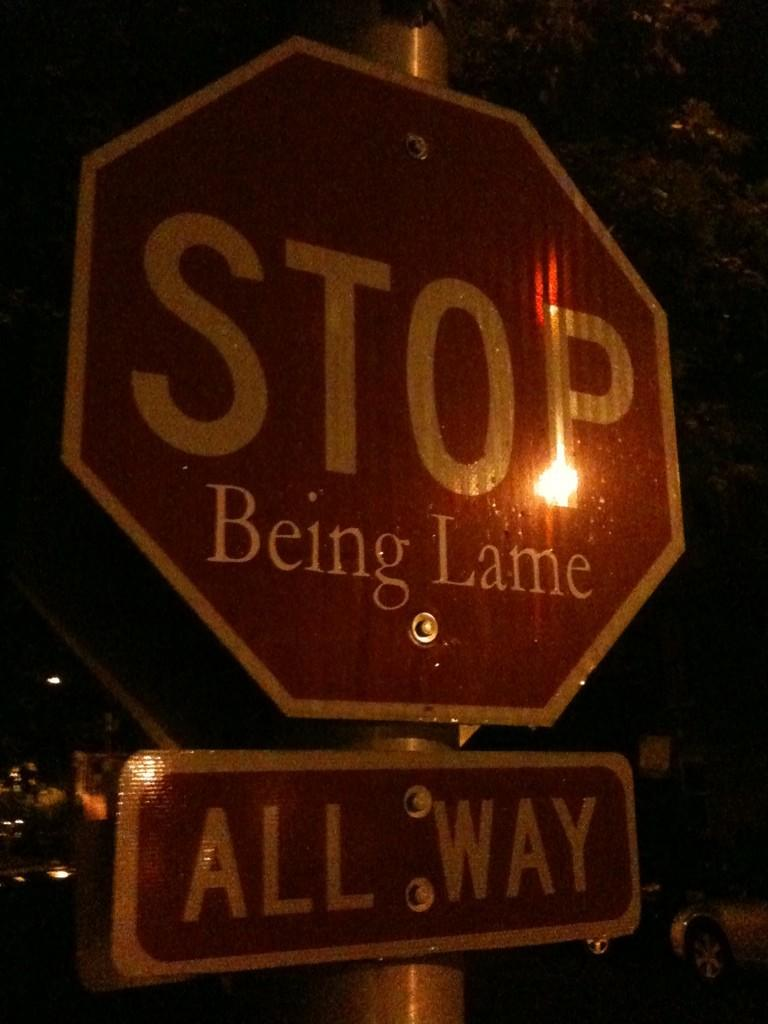<image>
Render a clear and concise summary of the photo. Big red and white stop sign with being lame wrote on it 